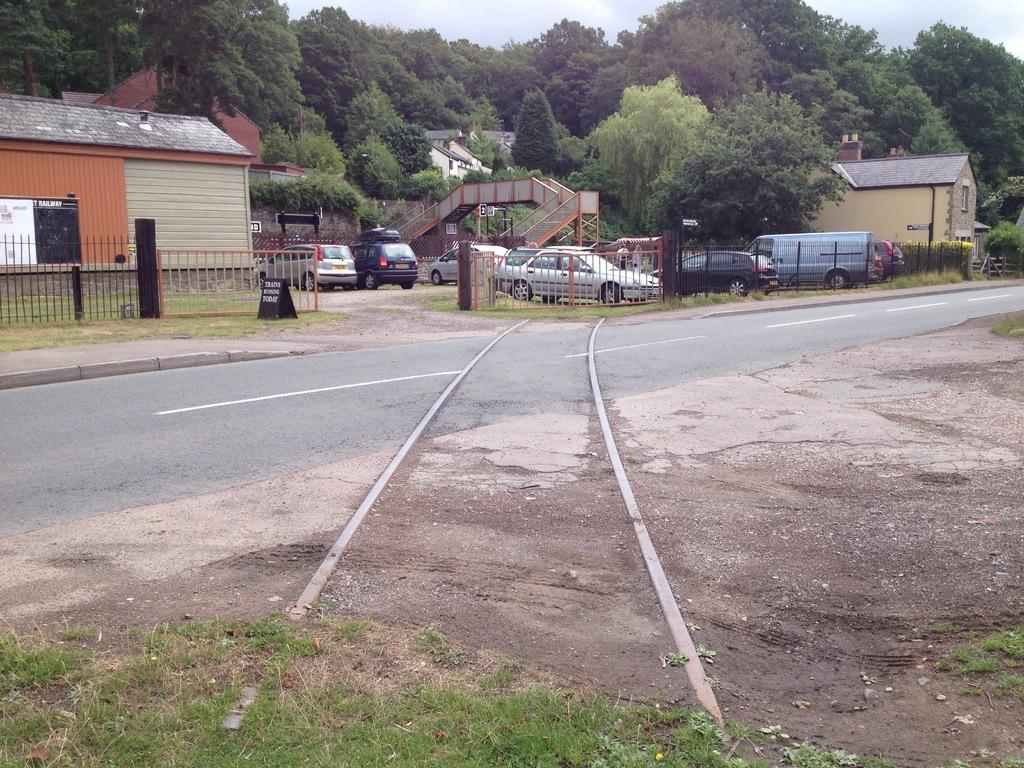Where was the image taken? The image was clicked outside. What can be seen at the top of the image? There are trees and the sky visible at the top of the image. What is located in the middle of the image? There are stores and cars in the middle of the image. What type of riddle is being solved by the trees in the image? There is no riddle being solved by the trees in the image; they are simply visible at the top of the image. 